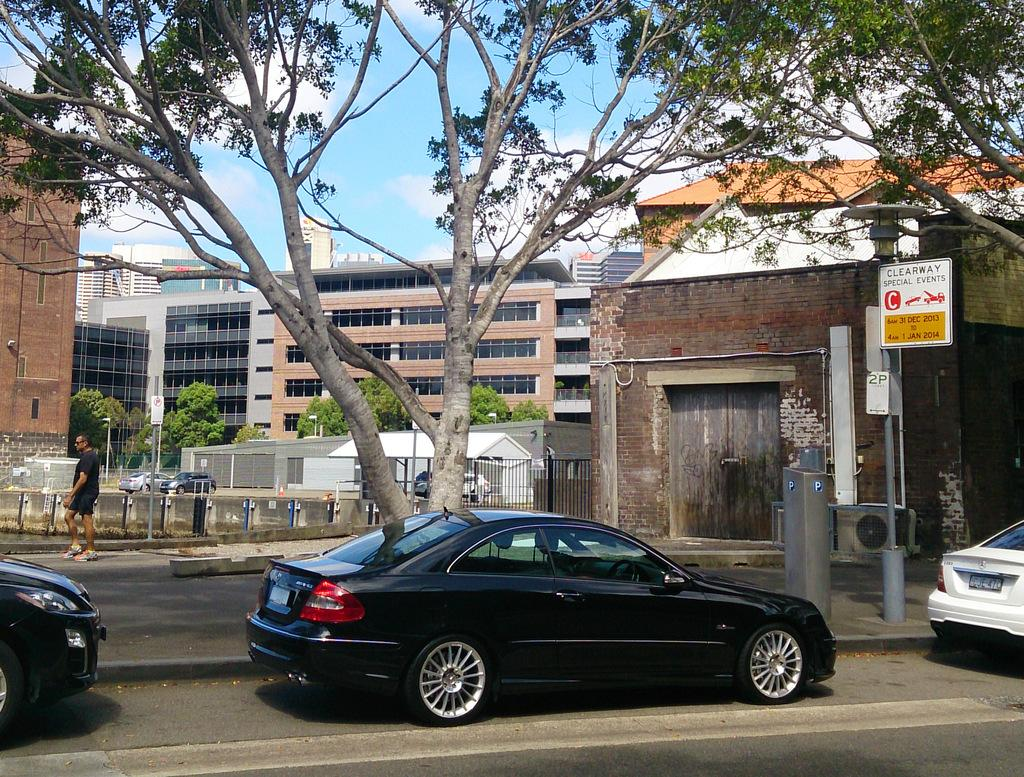What type of structures can be seen in the image? There are buildings in the image. What natural elements are present in the image? There are trees in the image. What type of barrier can be seen in the image? There is a fence in the image. What type of transportation is visible in the image? There are vehicles in the image. What object can be seen in the image that might be used for displaying information? There is a board in the image. What activity is a person engaged in within the image? There is a man walking in the image. How many chickens are present in the image? There are no chickens present in the image. What type of tool is being used by the man walking in the image? The man walking in the image is not using any tool, such as scissors. 